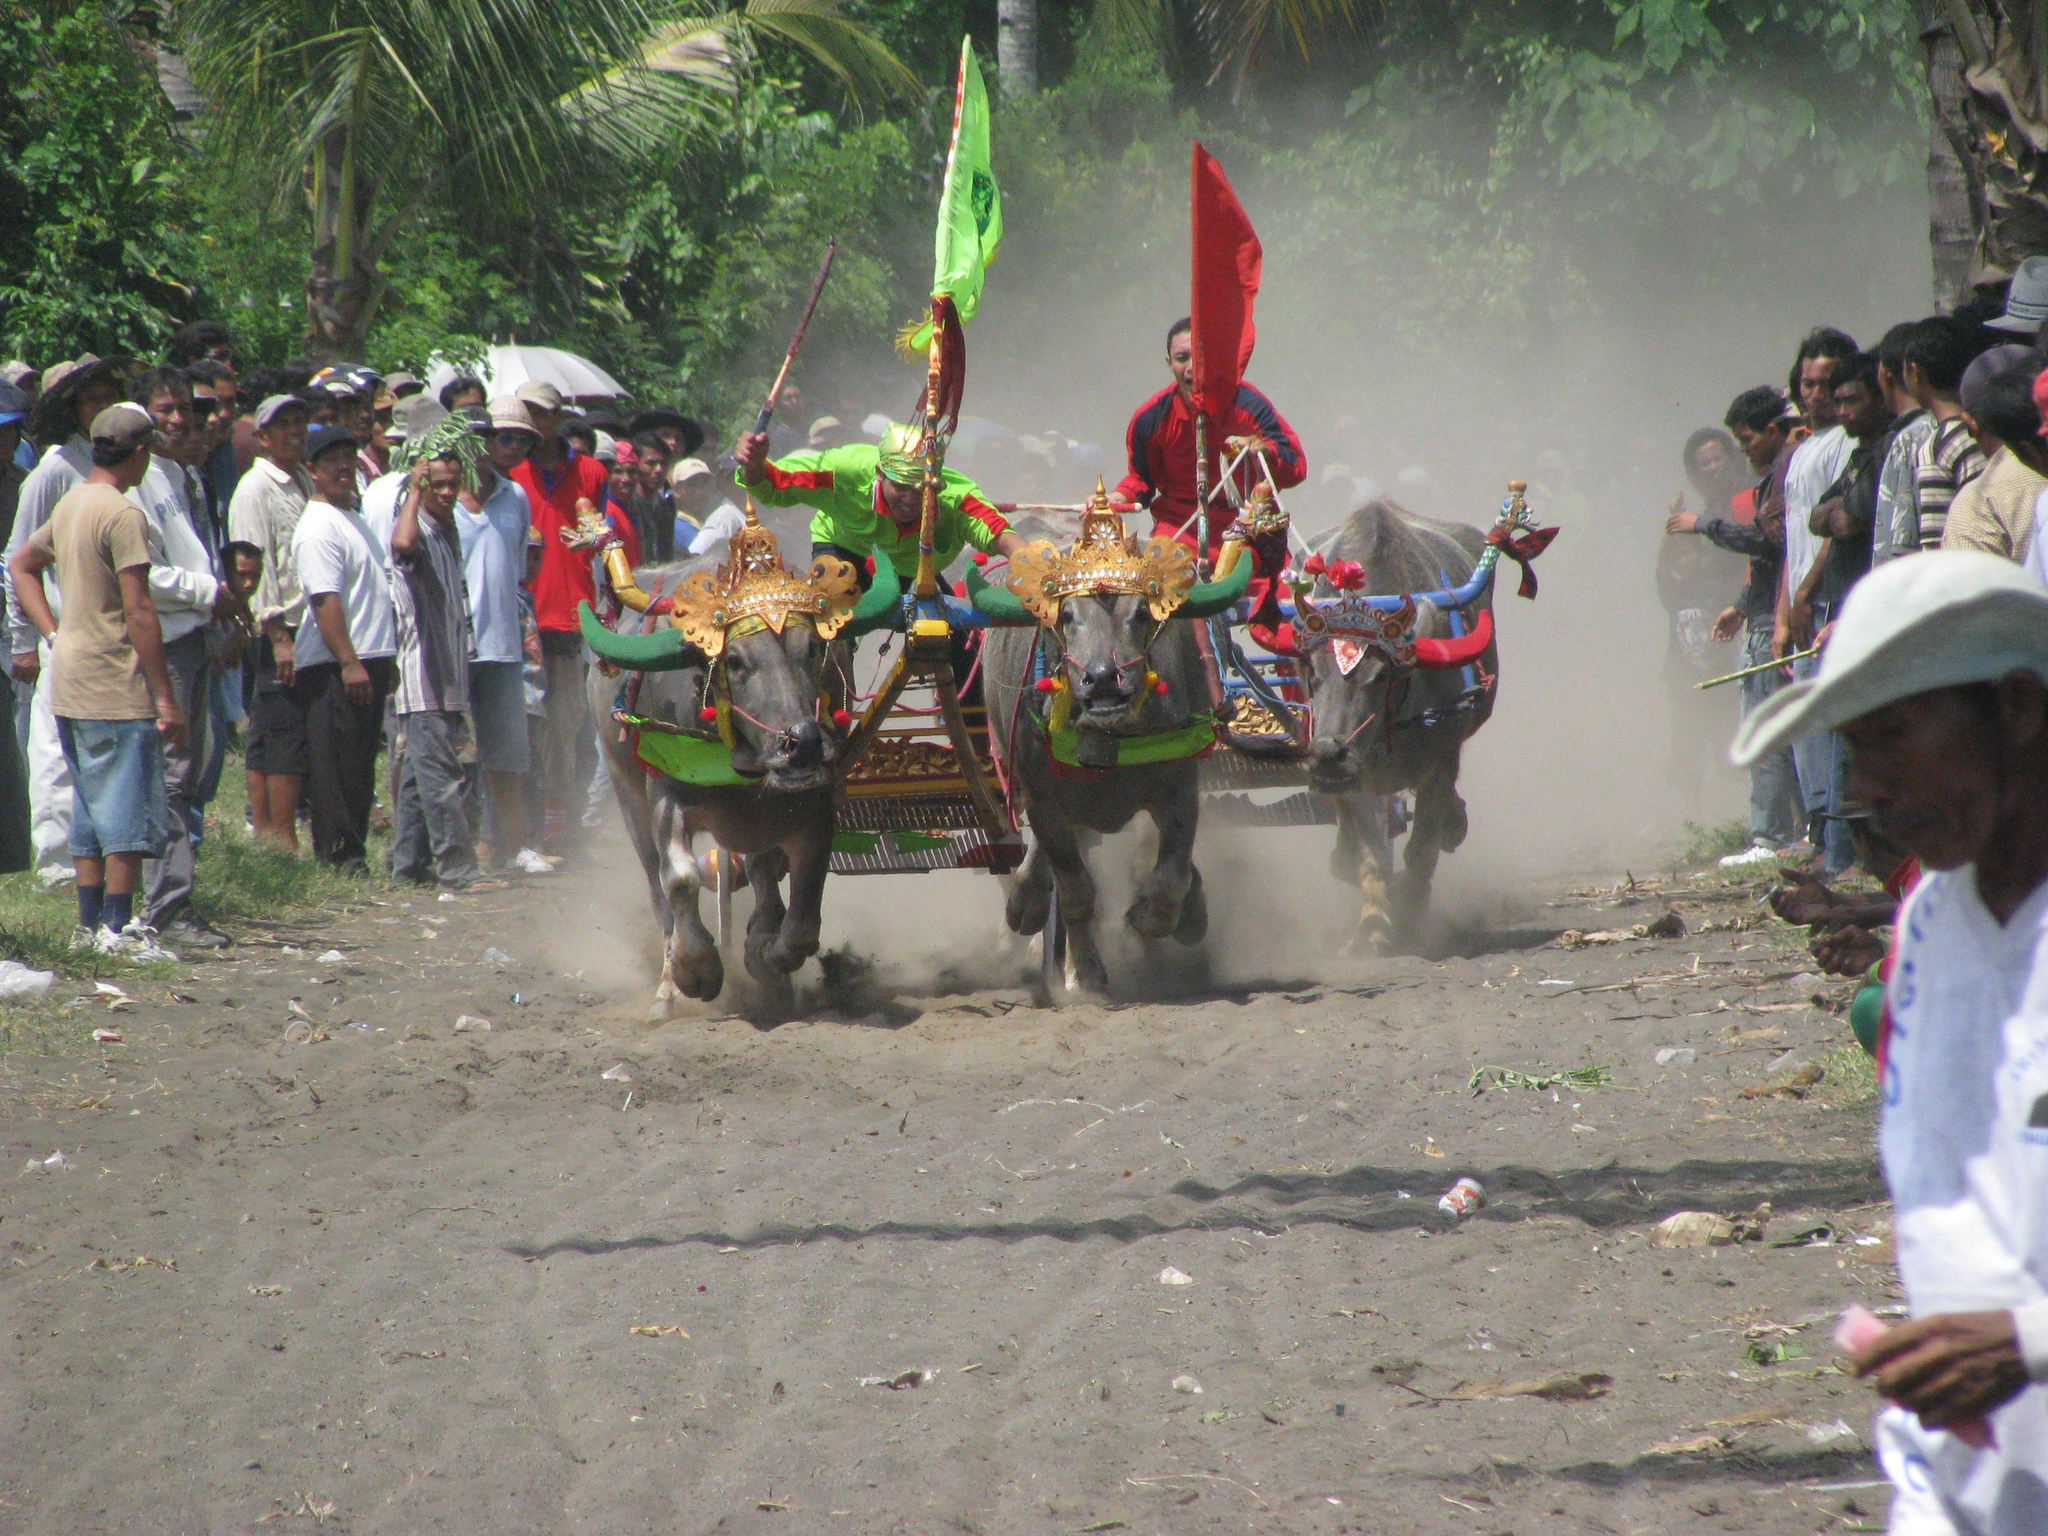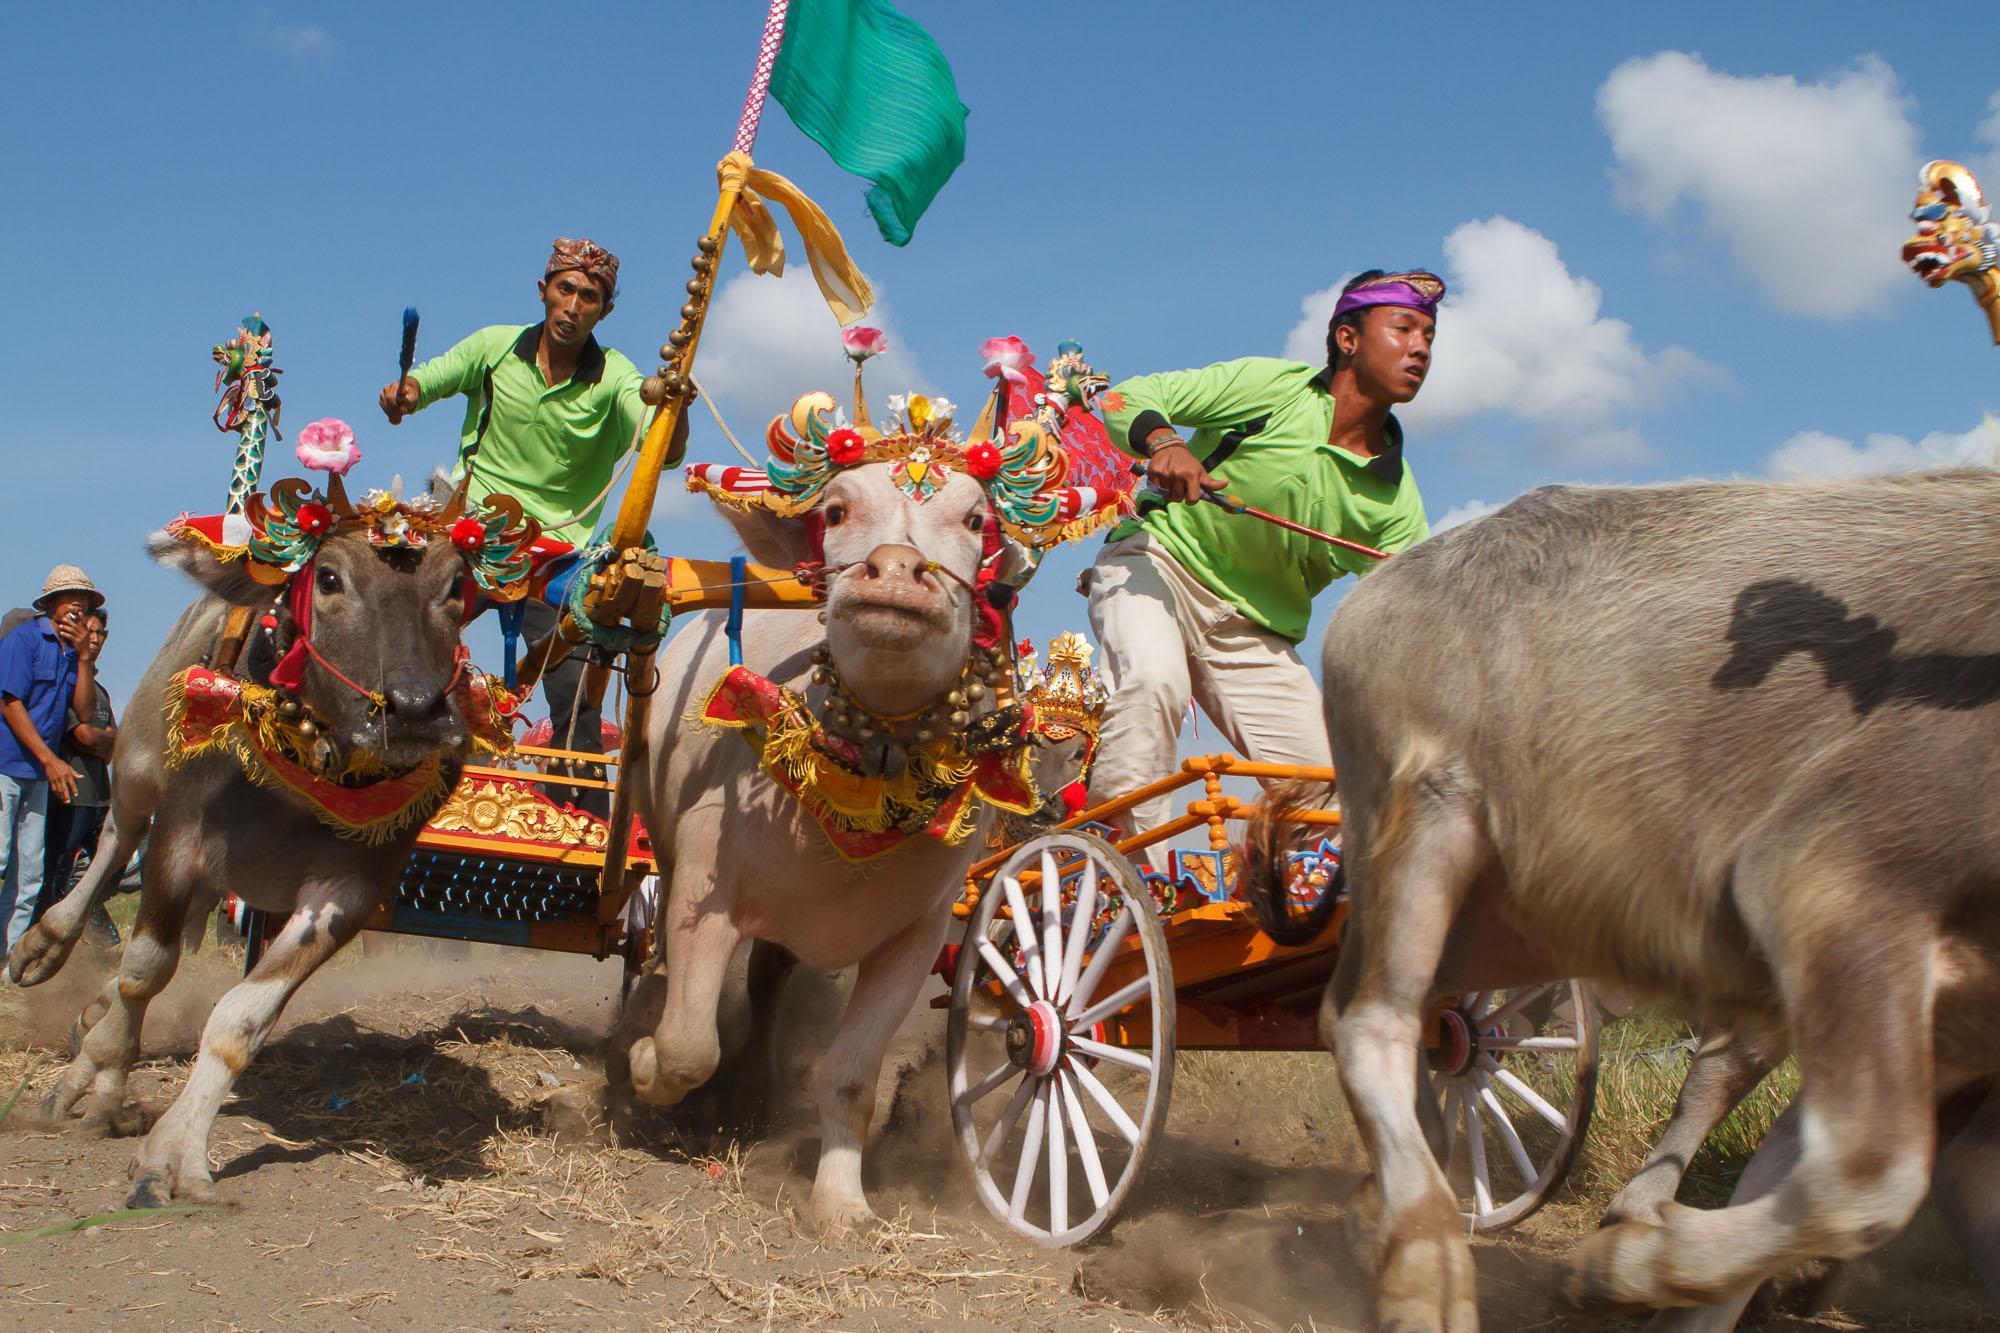The first image is the image on the left, the second image is the image on the right. Evaluate the accuracy of this statement regarding the images: "in at least one image there are two black bull in red headdress running right attached to a chaireate.". Is it true? Answer yes or no. No. The first image is the image on the left, the second image is the image on the right. Considering the images on both sides, is "In the right image, two ox-cart racers in green shirts are driving teams of two non-black oxen to the right." valid? Answer yes or no. Yes. 